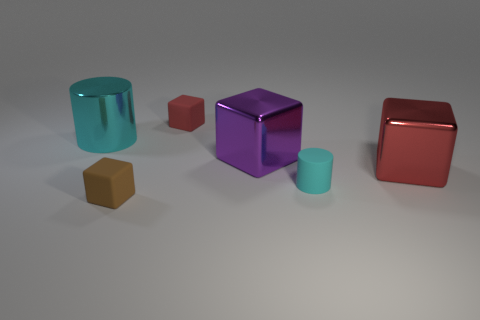Subtract all purple metal cubes. How many cubes are left? 3 Subtract 1 cylinders. How many cylinders are left? 1 Add 1 big blue things. How many objects exist? 7 Subtract all blocks. How many objects are left? 2 Subtract all purple cubes. How many cubes are left? 3 Add 6 tiny green blocks. How many tiny green blocks exist? 6 Subtract 0 green balls. How many objects are left? 6 Subtract all purple cylinders. Subtract all blue spheres. How many cylinders are left? 2 Subtract all yellow spheres. How many gray cubes are left? 0 Subtract all big metal cubes. Subtract all tiny green shiny cubes. How many objects are left? 4 